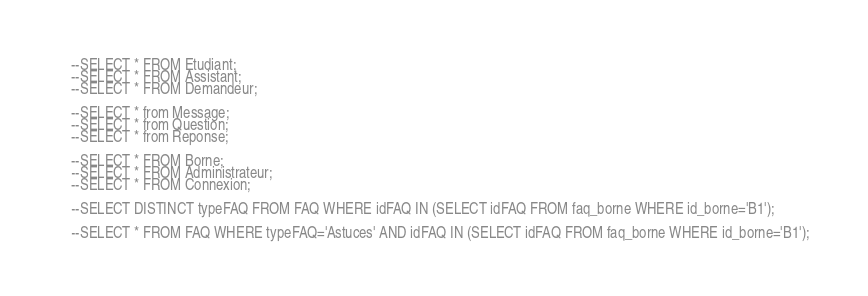Convert code to text. <code><loc_0><loc_0><loc_500><loc_500><_SQL_>--SELECT * FROM Etudiant;
--SELECT * FROM Assistant;
--SELECT * FROM Demandeur;

--SELECT * from Message;
--SELECT * from Question;
--SELECT * from Reponse;

--SELECT * FROM Borne;
--SELECT * FROM Administrateur;
--SELECT * FROM Connexion;

--SELECT DISTINCT typeFAQ FROM FAQ WHERE idFAQ IN (SELECT idFAQ FROM faq_borne WHERE id_borne='B1');

--SELECT * FROM FAQ WHERE typeFAQ='Astuces' AND idFAQ IN (SELECT idFAQ FROM faq_borne WHERE id_borne='B1');


</code> 